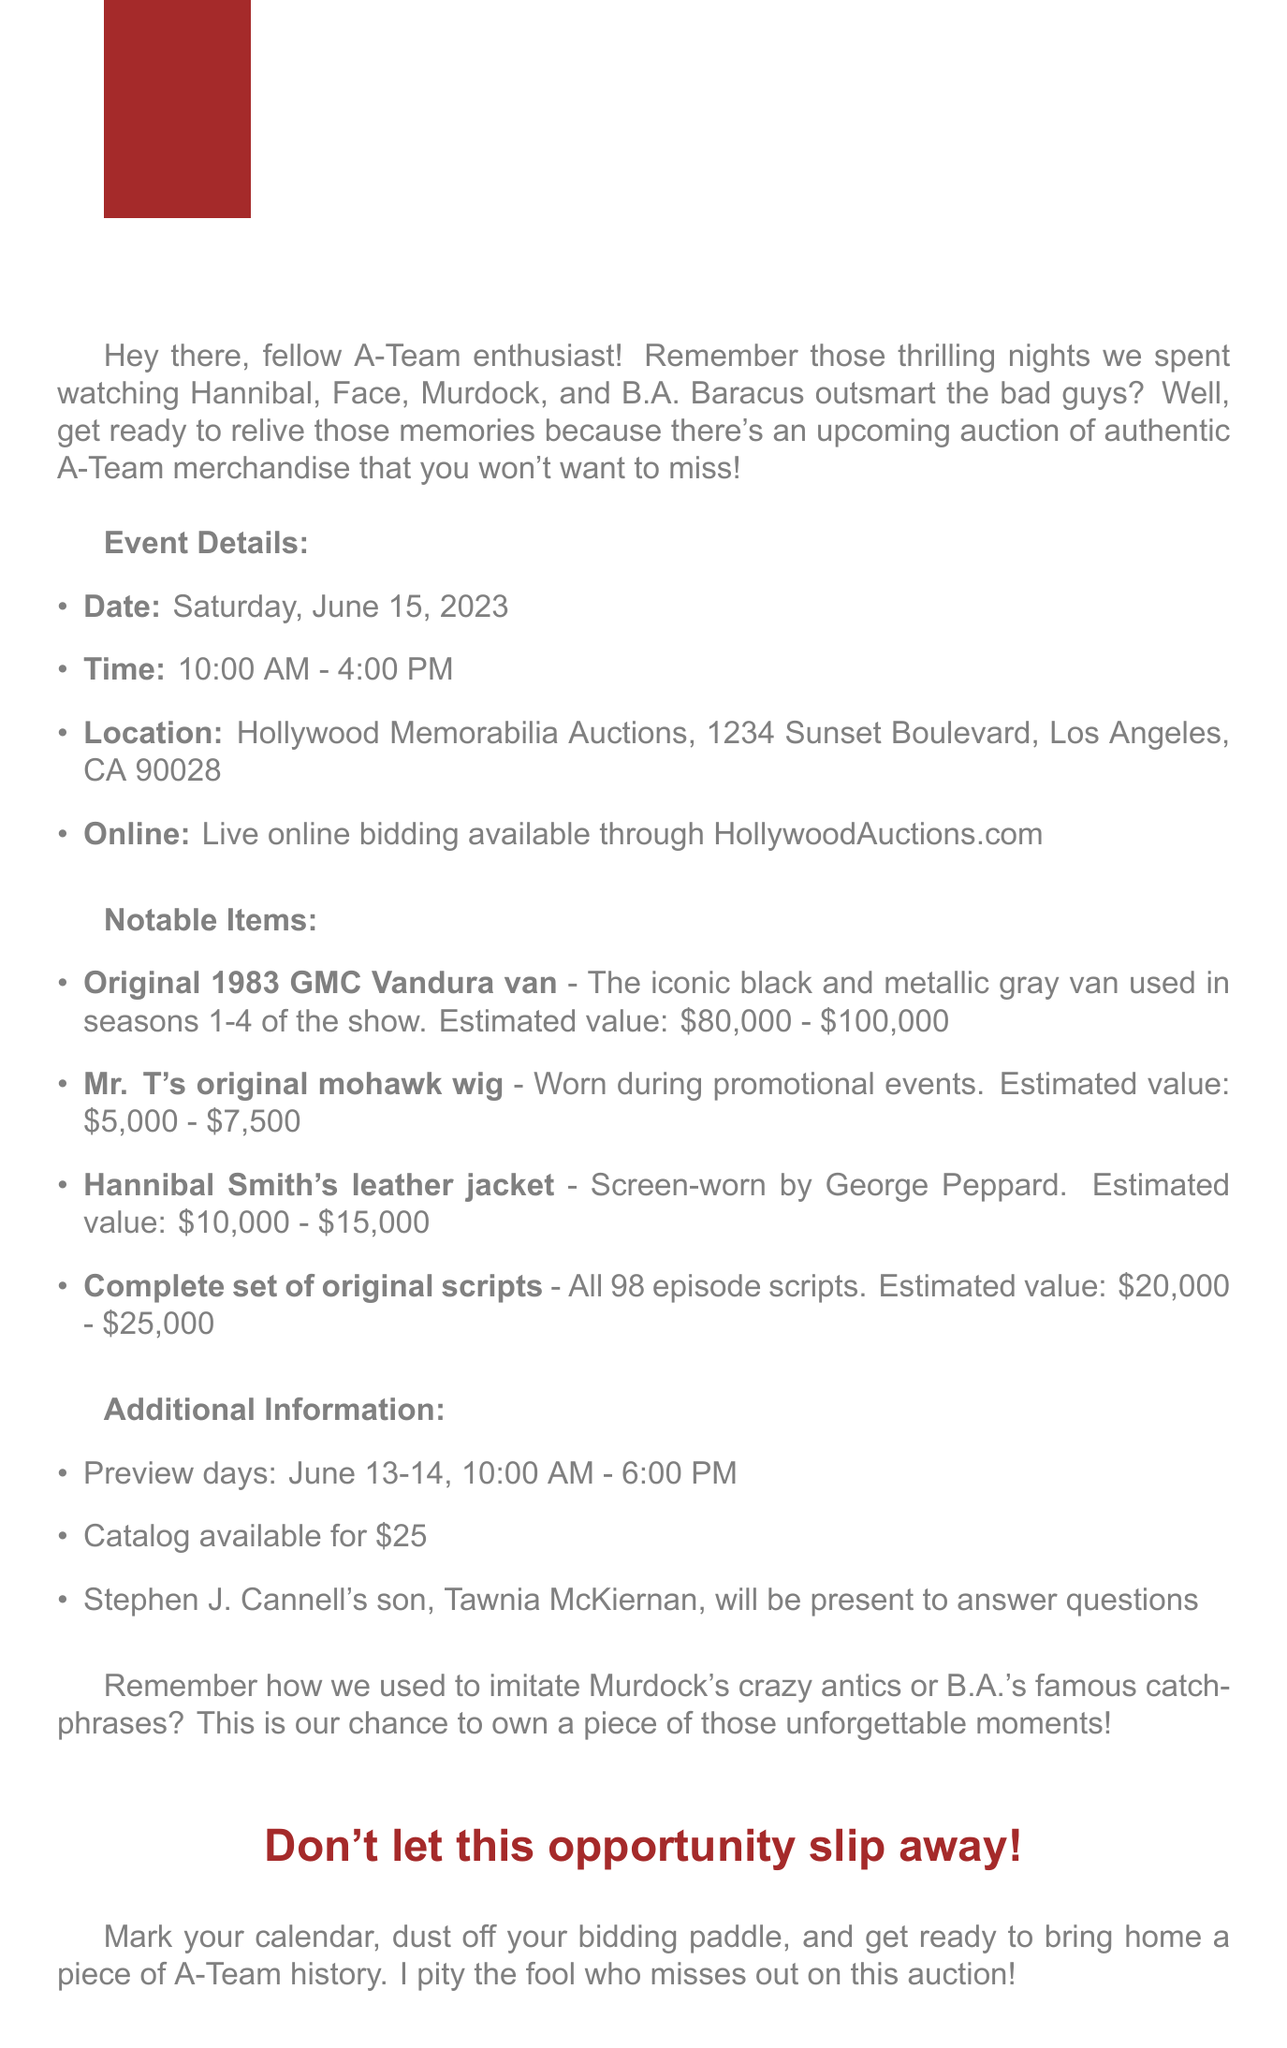What is the date of the auction? The date of the auction is explicitly mentioned in the event details section.
Answer: Saturday, June 15, 2023 What is the location of the auction? The location is provided in the event details section, highlighting where the auction will take place.
Answer: Hollywood Memorabilia Auctions, 1234 Sunset Boulevard, Los Angeles, CA 90028 What is the estimated value of Mr. T's mohawk wig? The estimated value is listed alongside the item's description in the notable items section.
Answer: $5,000 - $7,500 Who will be present at the auction to answer questions? This information is found in the additional information section, detailing who will be available for inquiries.
Answer: Tawnia McKiernan What are the preview days for the auction? The preview days are clearly stated in the additional information section, indicating when attendees can preview items.
Answer: June 13-14 What notable item is described as screen-worn by George Peppard? The document includes a note about which item was worn by George Peppard.
Answer: Hannibal Smith's leather jacket What time does the auction start? The start time is provided in the event details section, explicitly stating when the auction begins.
Answer: 10:00 AM What is the cost of the catalog? The document specifies the cost of the catalog in the additional information section.
Answer: $25 What is the estimated value range of the original GMC Vandura van? The estimated value range is listed in the notable items section as part of the item's details.
Answer: $80,000 - $100,000 